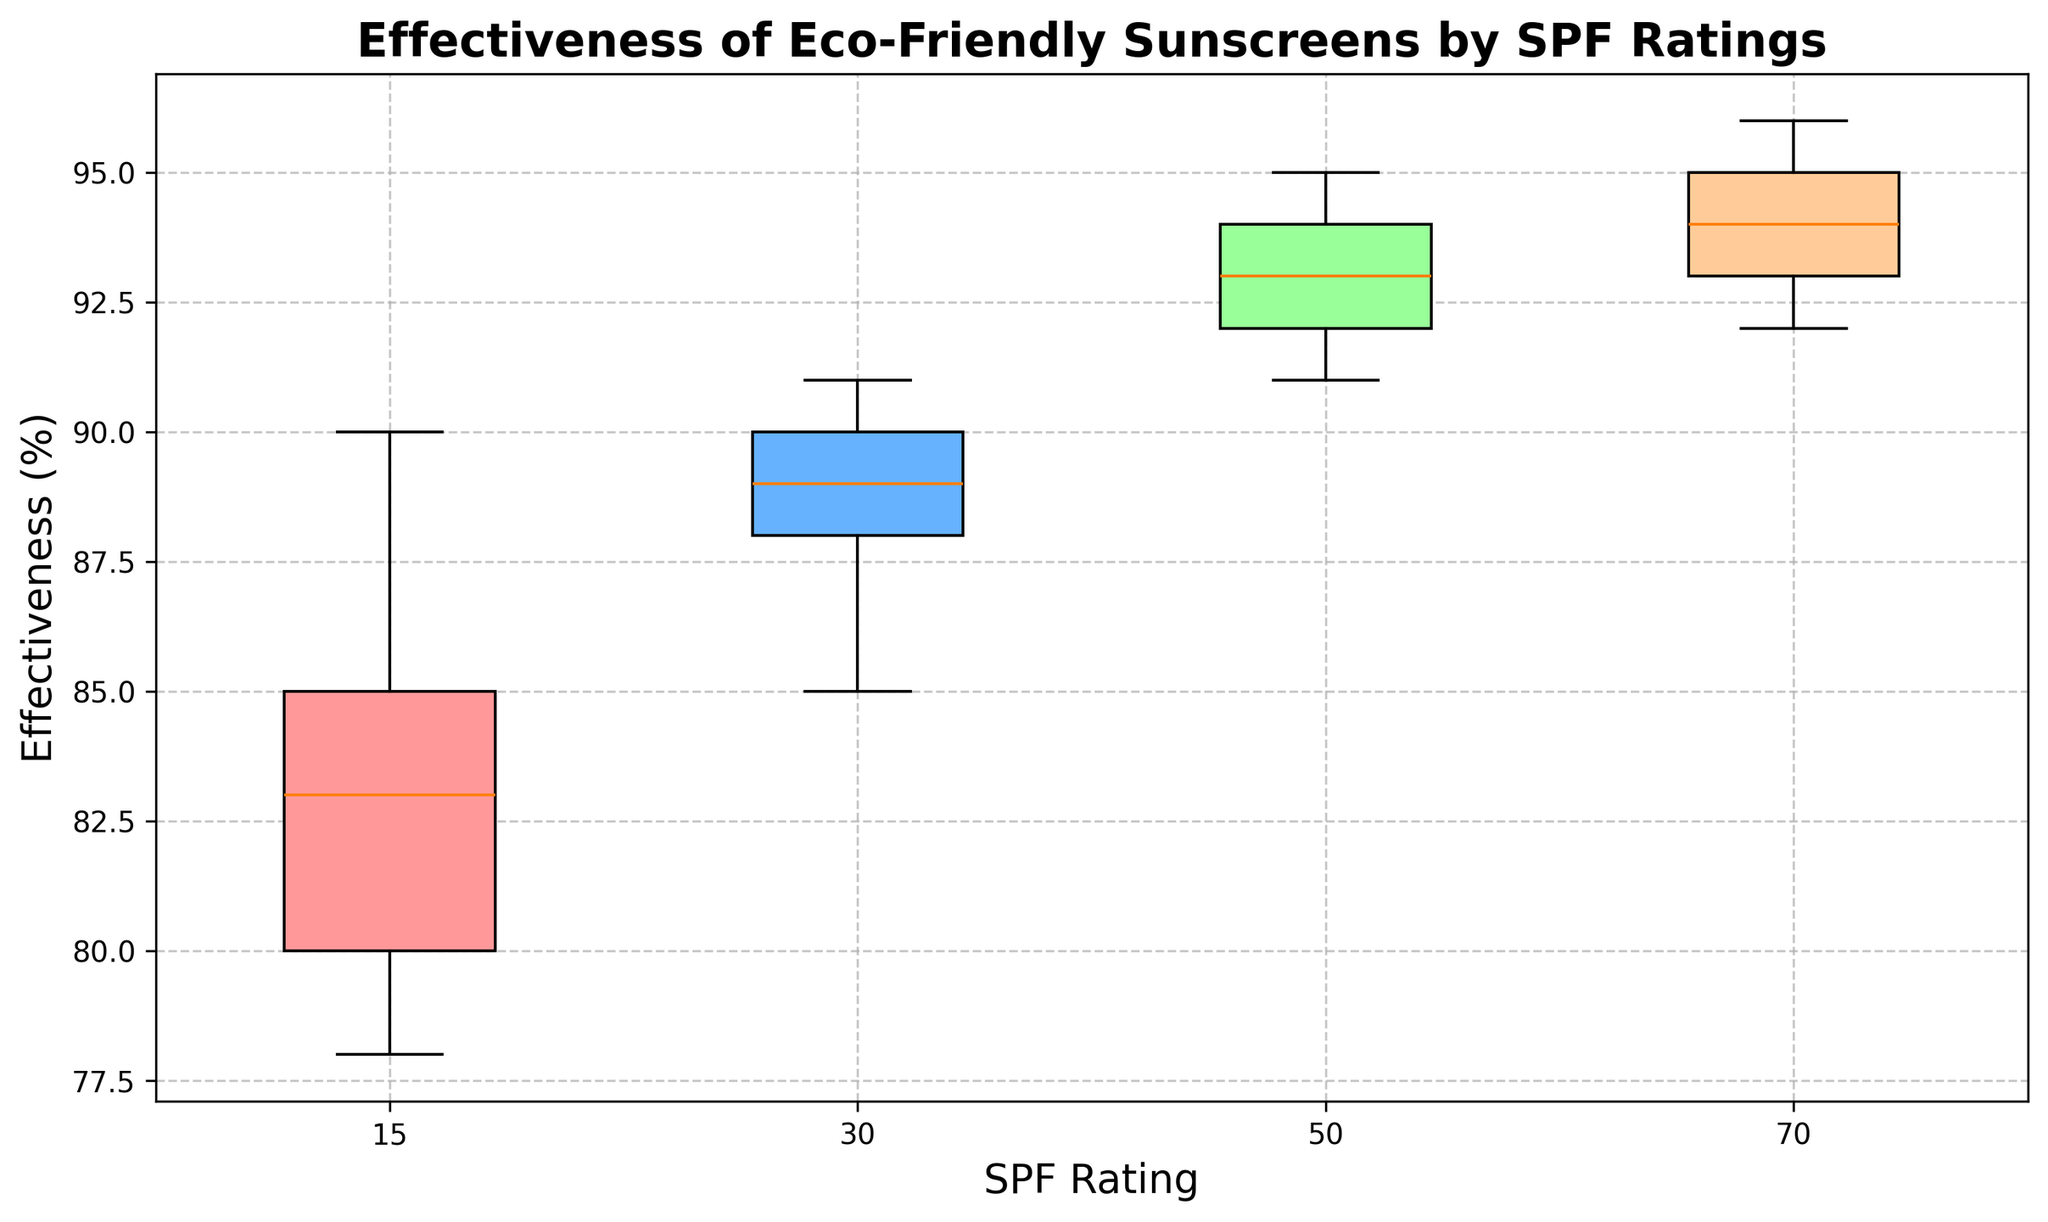What is the median effectiveness of sunscreens with SPF 15? To find the median effectiveness for SPF 15, list the effectiveness percentages (78, 80, 83, 85, 90). The median will be the middle value, which is 83.
Answer: 83 Which SPF rating has the highest median effectiveness? Compare the median values for each SPF rating. SPF 15 has a median of 83, SPF 30 has a median of 89, SPF 50 has a median of 93, and SPF 70 has a median of 94. SPF 70 has the highest median effectiveness.
Answer: SPF 70 How does the range of effectiveness for SPF 50 compare to that of SPF 15? The range is calculated by subtracting the minimum effectiveness from the maximum effectiveness. For SPF 50, the range is 95 - 91 = 4. For SPF 15, the range is 90 - 78 = 12. The range for SPF 15 is wider than for SPF 50.
Answer: SPF 15 has a wider range What is the color representing SPF 30 in the box plot? Identify the color of the box corresponding to SPF 30. It is the second box, which is filled with a blue color.
Answer: Blue Which SPF rating has the narrowest interquartile range (IQR)? The IQR is the range between the first quartile (Q1) and third quartile (Q3). Visually, SPF 50 has the narrowest box, indicating the smallest IQR compared to the other SPFs.
Answer: SPF 50 What is the difference between the upper quartile of SPF 30 and the upper quartile of SPF 70? The upper quartile is the top edge of the box plot. For SPF 30, the upper quartile appears around 90, and for SPF 70, it appears around 95. The difference is 95 - 90 = 5.
Answer: 5 Which SPF rating shows the highest variability in effectiveness? Variability can be inferred from the height of the box and the spread of the whiskers. SPF 15 has the tallest box and widest spread, suggesting it has the highest variability.
Answer: SPF 15 Is there any overlap in effectiveness between sunscreens with SPF 50 and SPF 70? Check if the whiskers and boxes of SPF 50 and SPF 70 intersect or overlap. Both SPF 50 and SPF 70 have their effectiveness values ranging mainly between 91-96, showing some overlap.
Answer: Yes What is the average median effectiveness of all SPF ratings? Calculate the median for each group: SPF 15 (83), SPF 30 (89), SPF 50 (93), SPF 70 (94). Sum these medians: 83 + 89 + 93 + 94 = 359. Then, divide by the number of groups (4): 359 / 4 = 89.75.
Answer: 89.75 Does SPF 50 or SPF 70 have a higher lowest effectiveness? Identify the lowest values at the bottom whisker for SPF 50 and SPF 70. The lowest effectiveness for SPF 50 is 91, and for SPF 70, it is 92. SPF 70 has the higher lowest effectiveness.
Answer: SPF 70 